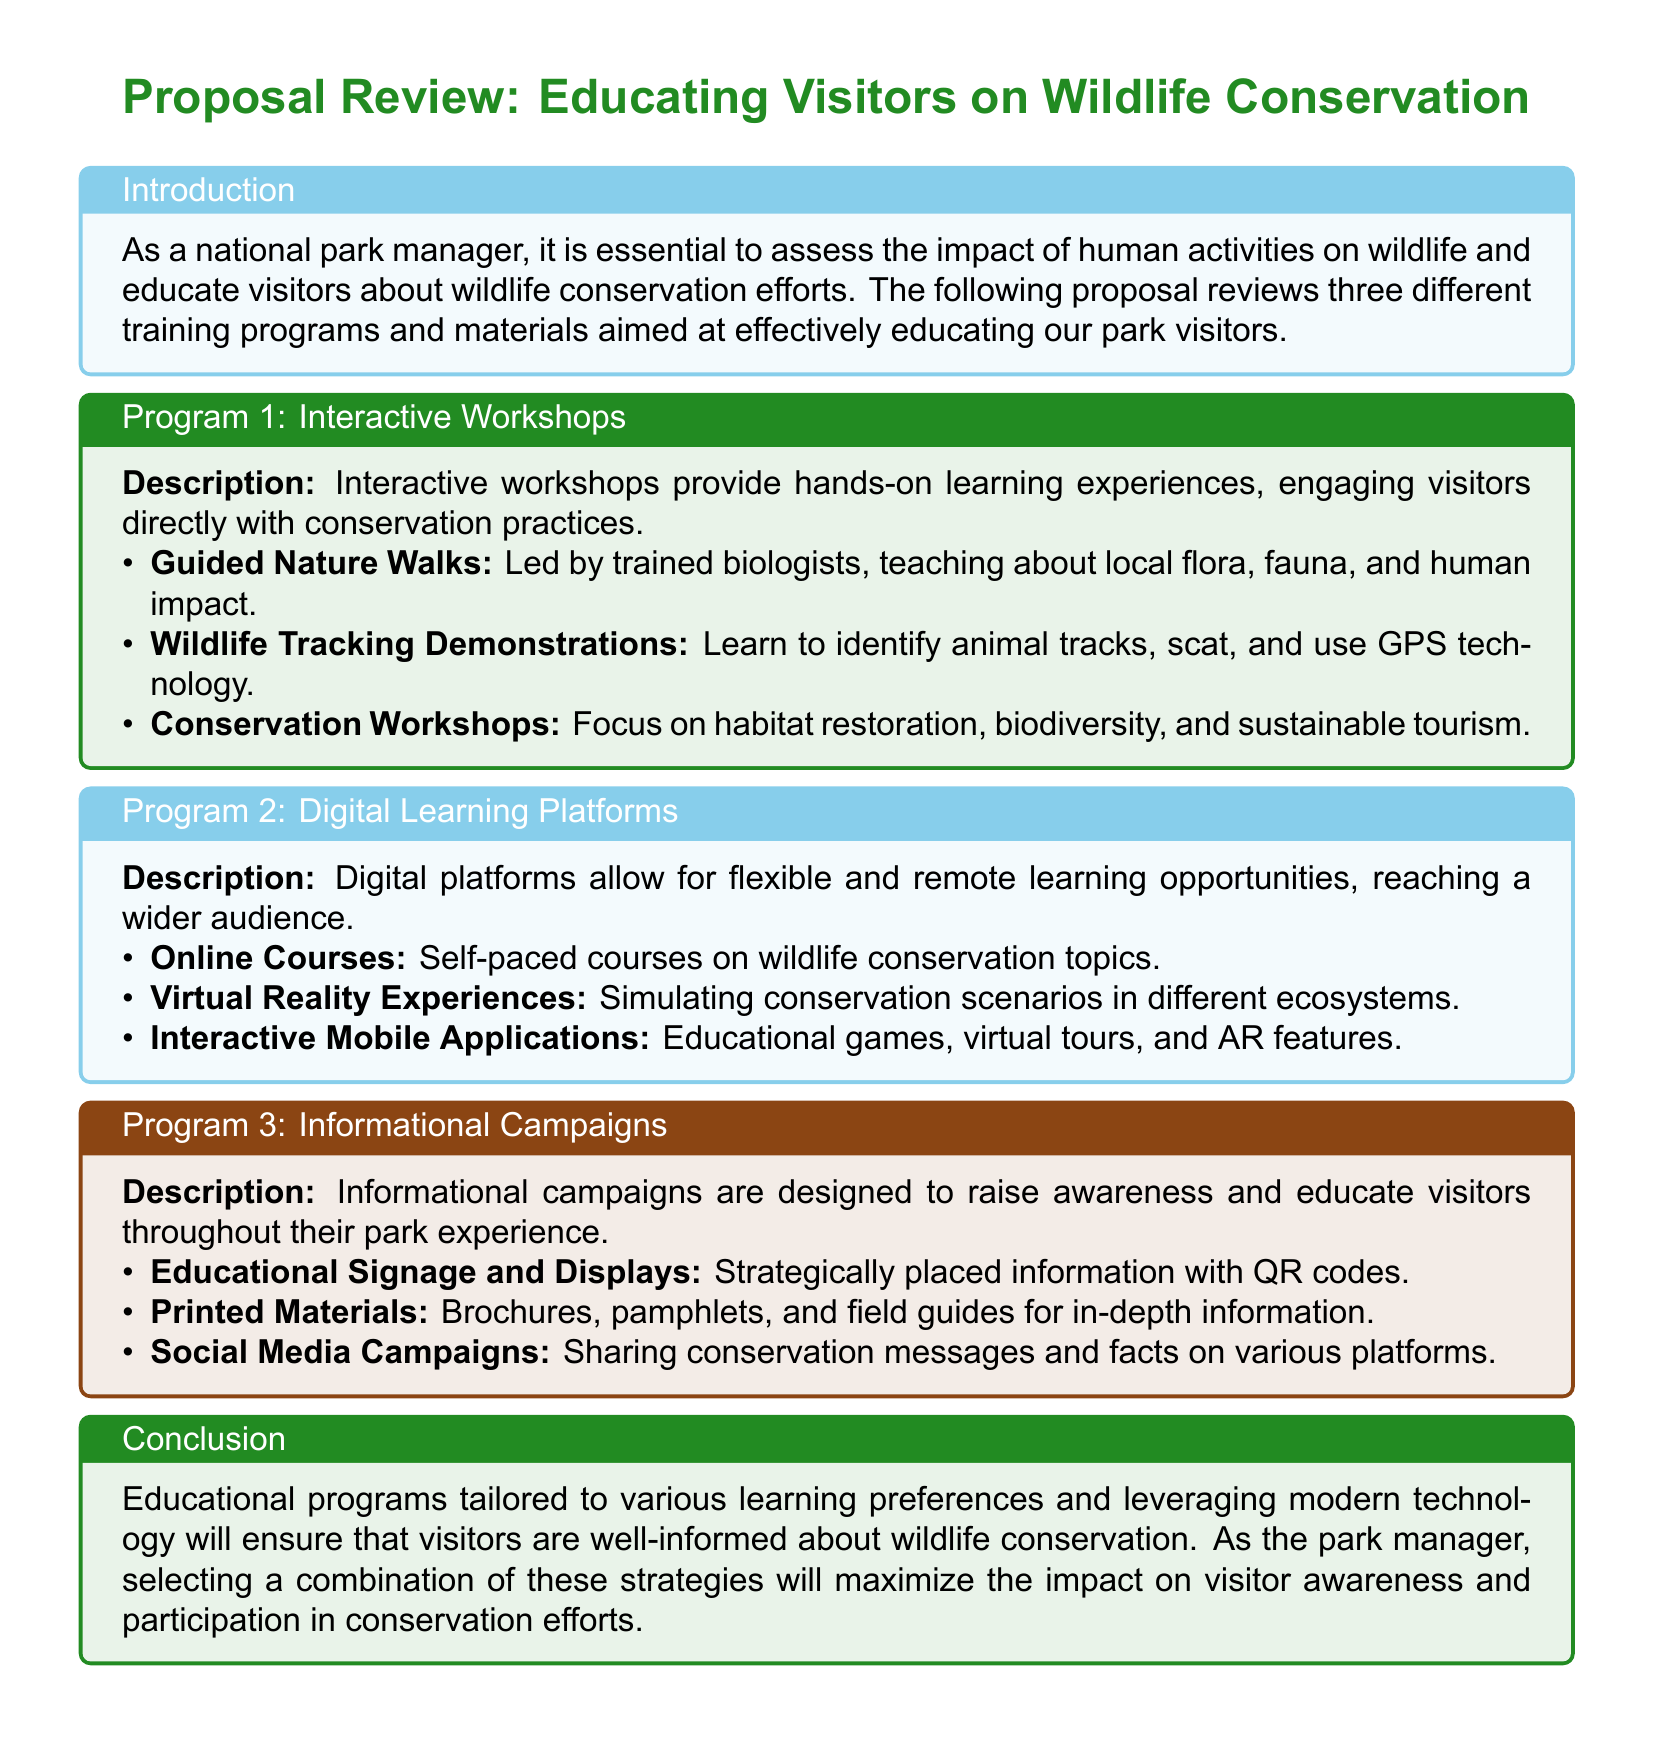What is the title of the proposal? The title of the proposal is clearly stated at the top of the document as "Proposal Review: Educating Visitors on Wildlife Conservation."
Answer: Proposal Review: Educating Visitors on Wildlife Conservation How many training programs are reviewed in the proposal? The document outlines three different training programs aimed at educating visitors.
Answer: Three What is the main focus of Program 1? Program 1 focuses on interactive learning experiences that engage visitors directly with conservation practices.
Answer: Interactive Workshops What technology is mentioned in Program 2 for simulating scenarios? The document mentions virtual reality experiences as a part of the digital learning platforms outlined in Program 2.
Answer: Virtual Reality Experiences What type of materials are included in Program 3? Program 3 includes printed materials such as brochures and pamphlets to provide in-depth information to park visitors.
Answer: Printed Materials Which program includes guided nature walks? The guided nature walks are part of Program 1, specifically labeled as a hands-on learning experience.
Answer: Program 1 What is the overarching goal of the educational programs? The overarching goal is to ensure that visitors are well-informed about wildlife conservation.
Answer: Educating visitors What feature is included in informational campaigns for raising awareness? The campaigns include educational signage and displays strategically placed throughout the park.
Answer: Educational Signage and Displays 